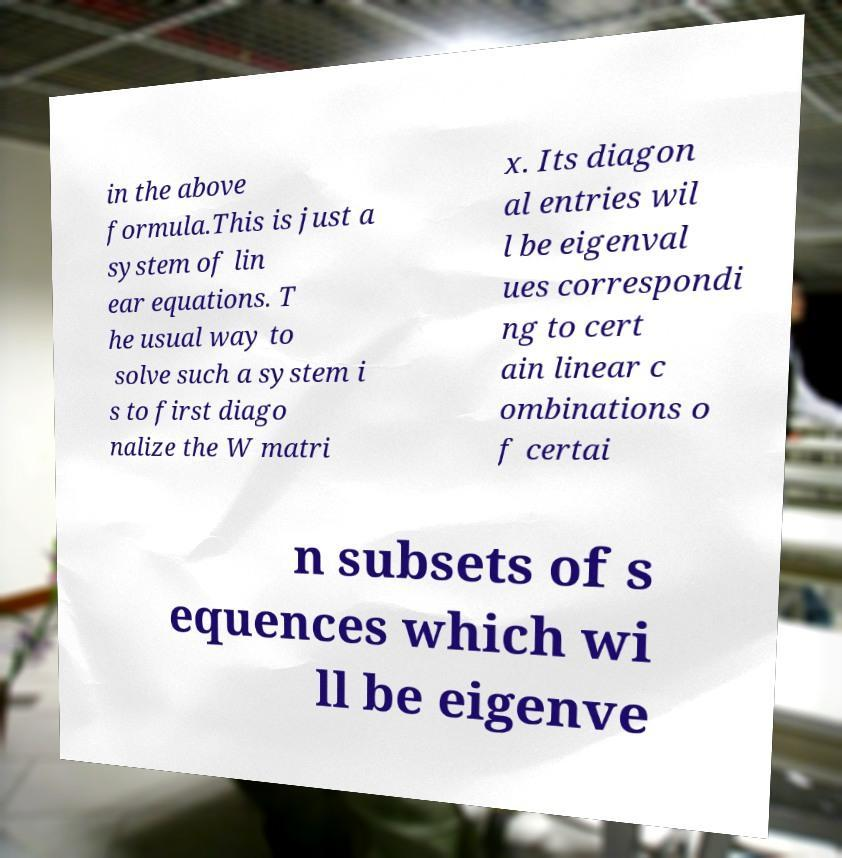Could you extract and type out the text from this image? in the above formula.This is just a system of lin ear equations. T he usual way to solve such a system i s to first diago nalize the W matri x. Its diagon al entries wil l be eigenval ues correspondi ng to cert ain linear c ombinations o f certai n subsets of s equences which wi ll be eigenve 